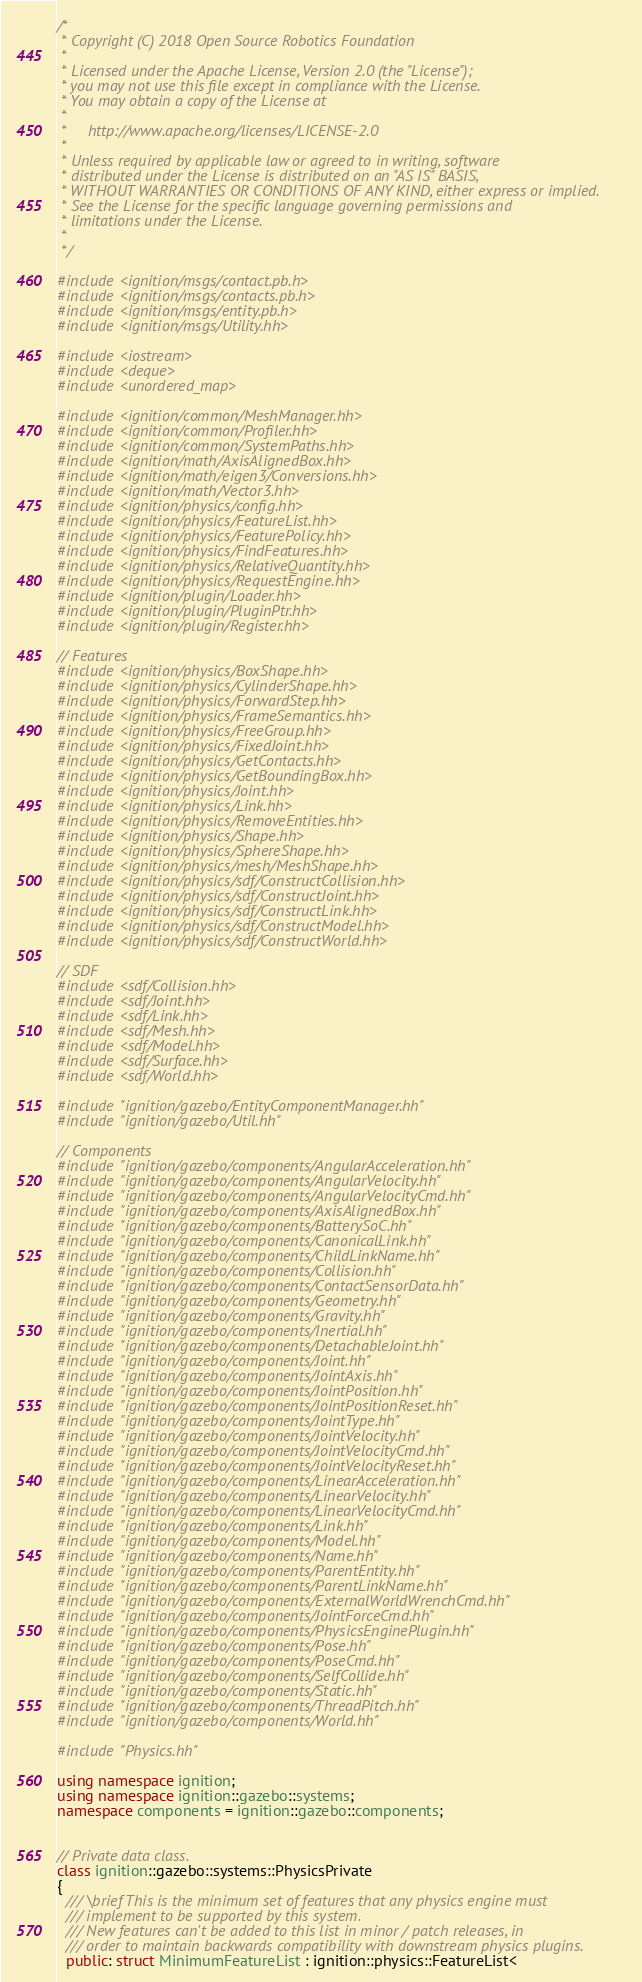Convert code to text. <code><loc_0><loc_0><loc_500><loc_500><_C++_>/*
 * Copyright (C) 2018 Open Source Robotics Foundation
 *
 * Licensed under the Apache License, Version 2.0 (the "License");
 * you may not use this file except in compliance with the License.
 * You may obtain a copy of the License at
 *
 *     http://www.apache.org/licenses/LICENSE-2.0
 *
 * Unless required by applicable law or agreed to in writing, software
 * distributed under the License is distributed on an "AS IS" BASIS,
 * WITHOUT WARRANTIES OR CONDITIONS OF ANY KIND, either express or implied.
 * See the License for the specific language governing permissions and
 * limitations under the License.
 *
 */

#include <ignition/msgs/contact.pb.h>
#include <ignition/msgs/contacts.pb.h>
#include <ignition/msgs/entity.pb.h>
#include <ignition/msgs/Utility.hh>

#include <iostream>
#include <deque>
#include <unordered_map>

#include <ignition/common/MeshManager.hh>
#include <ignition/common/Profiler.hh>
#include <ignition/common/SystemPaths.hh>
#include <ignition/math/AxisAlignedBox.hh>
#include <ignition/math/eigen3/Conversions.hh>
#include <ignition/math/Vector3.hh>
#include <ignition/physics/config.hh>
#include <ignition/physics/FeatureList.hh>
#include <ignition/physics/FeaturePolicy.hh>
#include <ignition/physics/FindFeatures.hh>
#include <ignition/physics/RelativeQuantity.hh>
#include <ignition/physics/RequestEngine.hh>
#include <ignition/plugin/Loader.hh>
#include <ignition/plugin/PluginPtr.hh>
#include <ignition/plugin/Register.hh>

// Features
#include <ignition/physics/BoxShape.hh>
#include <ignition/physics/CylinderShape.hh>
#include <ignition/physics/ForwardStep.hh>
#include <ignition/physics/FrameSemantics.hh>
#include <ignition/physics/FreeGroup.hh>
#include <ignition/physics/FixedJoint.hh>
#include <ignition/physics/GetContacts.hh>
#include <ignition/physics/GetBoundingBox.hh>
#include <ignition/physics/Joint.hh>
#include <ignition/physics/Link.hh>
#include <ignition/physics/RemoveEntities.hh>
#include <ignition/physics/Shape.hh>
#include <ignition/physics/SphereShape.hh>
#include <ignition/physics/mesh/MeshShape.hh>
#include <ignition/physics/sdf/ConstructCollision.hh>
#include <ignition/physics/sdf/ConstructJoint.hh>
#include <ignition/physics/sdf/ConstructLink.hh>
#include <ignition/physics/sdf/ConstructModel.hh>
#include <ignition/physics/sdf/ConstructWorld.hh>

// SDF
#include <sdf/Collision.hh>
#include <sdf/Joint.hh>
#include <sdf/Link.hh>
#include <sdf/Mesh.hh>
#include <sdf/Model.hh>
#include <sdf/Surface.hh>
#include <sdf/World.hh>

#include "ignition/gazebo/EntityComponentManager.hh"
#include "ignition/gazebo/Util.hh"

// Components
#include "ignition/gazebo/components/AngularAcceleration.hh"
#include "ignition/gazebo/components/AngularVelocity.hh"
#include "ignition/gazebo/components/AngularVelocityCmd.hh"
#include "ignition/gazebo/components/AxisAlignedBox.hh"
#include "ignition/gazebo/components/BatterySoC.hh"
#include "ignition/gazebo/components/CanonicalLink.hh"
#include "ignition/gazebo/components/ChildLinkName.hh"
#include "ignition/gazebo/components/Collision.hh"
#include "ignition/gazebo/components/ContactSensorData.hh"
#include "ignition/gazebo/components/Geometry.hh"
#include "ignition/gazebo/components/Gravity.hh"
#include "ignition/gazebo/components/Inertial.hh"
#include "ignition/gazebo/components/DetachableJoint.hh"
#include "ignition/gazebo/components/Joint.hh"
#include "ignition/gazebo/components/JointAxis.hh"
#include "ignition/gazebo/components/JointPosition.hh"
#include "ignition/gazebo/components/JointPositionReset.hh"
#include "ignition/gazebo/components/JointType.hh"
#include "ignition/gazebo/components/JointVelocity.hh"
#include "ignition/gazebo/components/JointVelocityCmd.hh"
#include "ignition/gazebo/components/JointVelocityReset.hh"
#include "ignition/gazebo/components/LinearAcceleration.hh"
#include "ignition/gazebo/components/LinearVelocity.hh"
#include "ignition/gazebo/components/LinearVelocityCmd.hh"
#include "ignition/gazebo/components/Link.hh"
#include "ignition/gazebo/components/Model.hh"
#include "ignition/gazebo/components/Name.hh"
#include "ignition/gazebo/components/ParentEntity.hh"
#include "ignition/gazebo/components/ParentLinkName.hh"
#include "ignition/gazebo/components/ExternalWorldWrenchCmd.hh"
#include "ignition/gazebo/components/JointForceCmd.hh"
#include "ignition/gazebo/components/PhysicsEnginePlugin.hh"
#include "ignition/gazebo/components/Pose.hh"
#include "ignition/gazebo/components/PoseCmd.hh"
#include "ignition/gazebo/components/SelfCollide.hh"
#include "ignition/gazebo/components/Static.hh"
#include "ignition/gazebo/components/ThreadPitch.hh"
#include "ignition/gazebo/components/World.hh"

#include "Physics.hh"

using namespace ignition;
using namespace ignition::gazebo::systems;
namespace components = ignition::gazebo::components;


// Private data class.
class ignition::gazebo::systems::PhysicsPrivate
{
  /// \brief This is the minimum set of features that any physics engine must
  /// implement to be supported by this system.
  /// New features can't be added to this list in minor / patch releases, in
  /// order to maintain backwards compatibility with downstream physics plugins.
  public: struct MinimumFeatureList : ignition::physics::FeatureList<</code> 